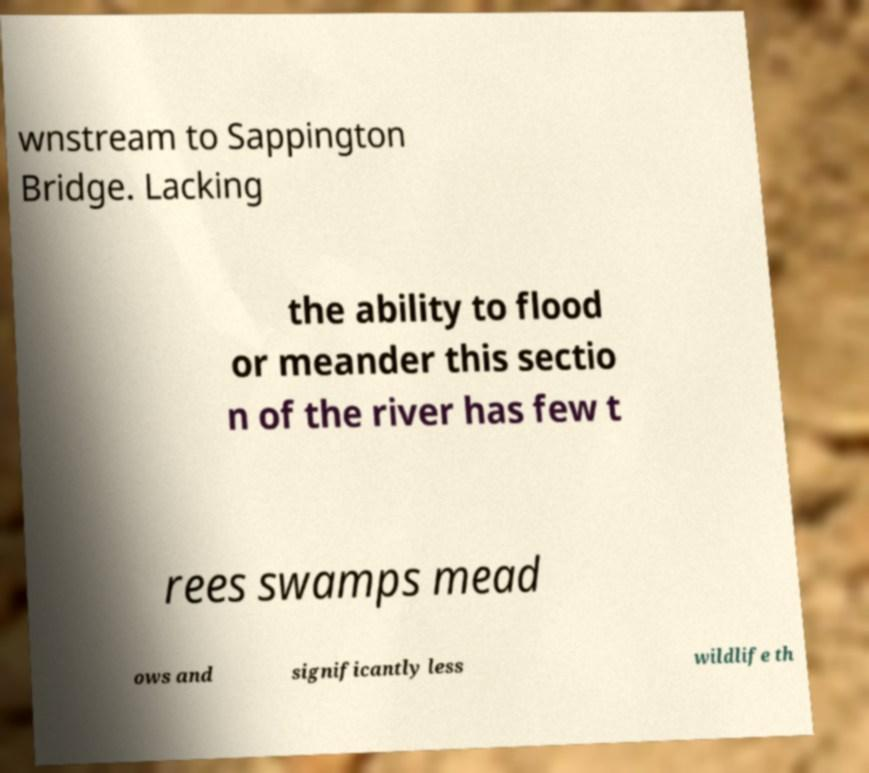What messages or text are displayed in this image? I need them in a readable, typed format. wnstream to Sappington Bridge. Lacking the ability to flood or meander this sectio n of the river has few t rees swamps mead ows and significantly less wildlife th 